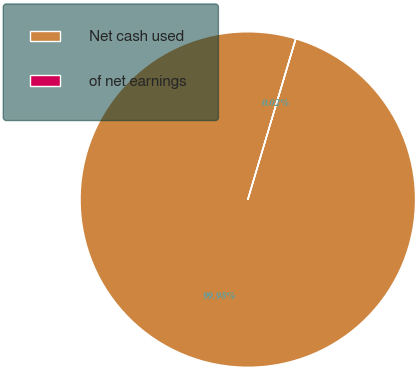Convert chart to OTSL. <chart><loc_0><loc_0><loc_500><loc_500><pie_chart><fcel>Net cash used<fcel>of net earnings<nl><fcel>99.98%<fcel>0.02%<nl></chart> 